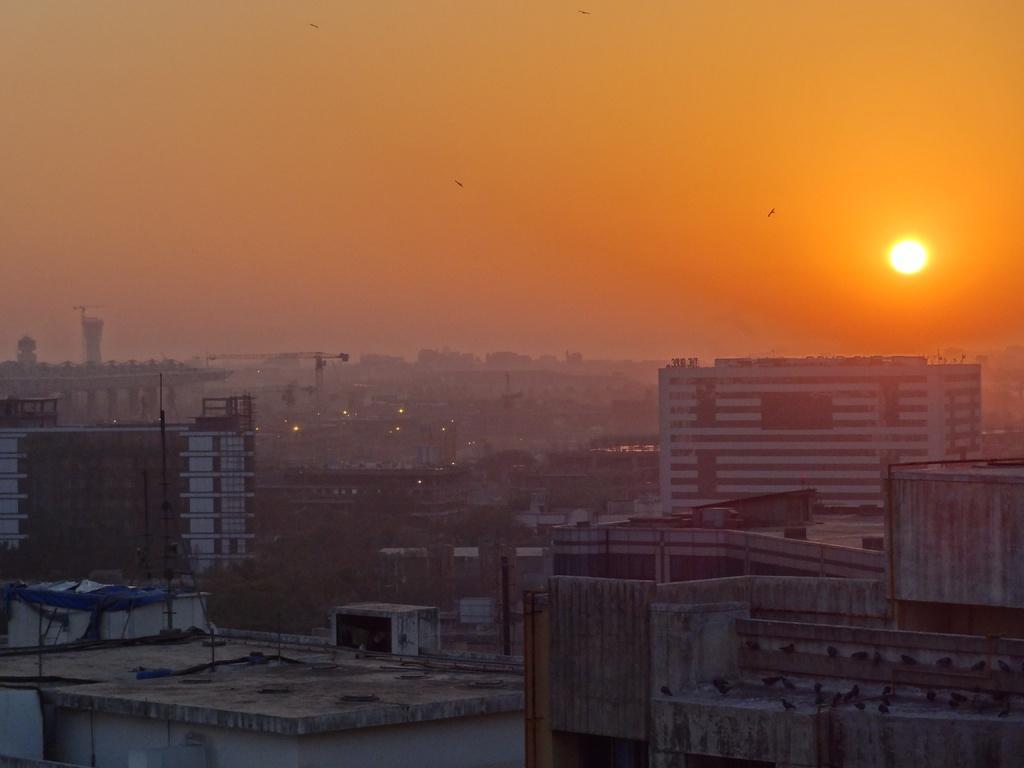Describe this image in one or two sentences. In this image at the bottom there are some houses, buildings and some poles. At the top of the image there is sky, sun and some birds. 